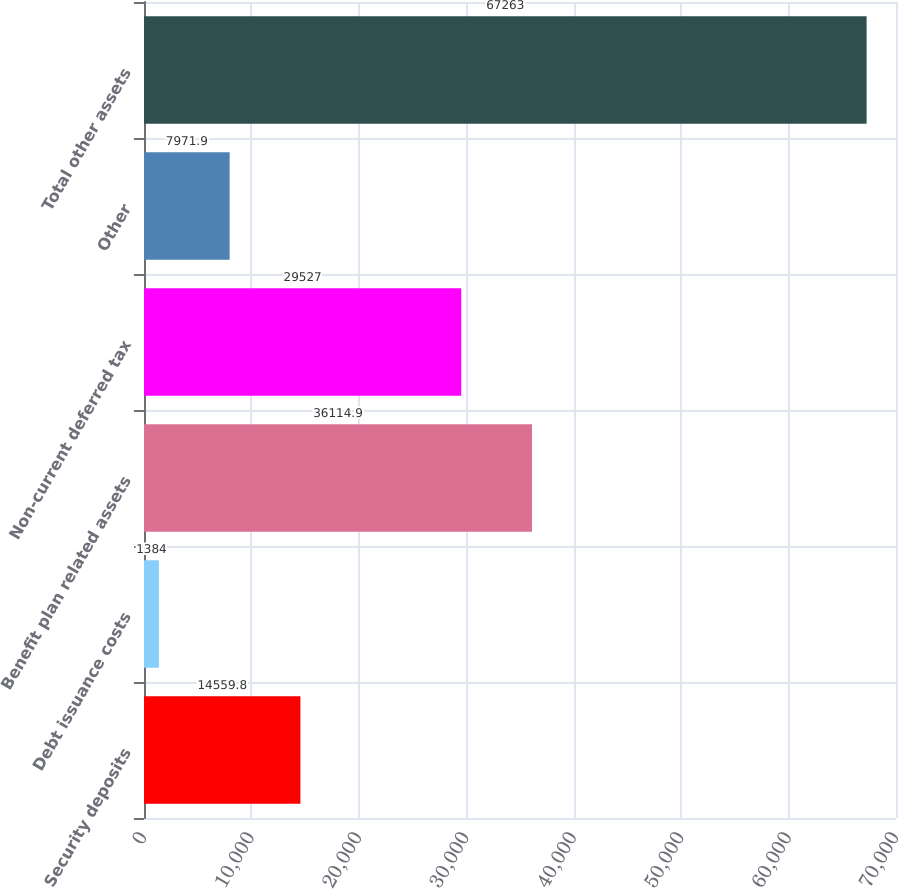Convert chart. <chart><loc_0><loc_0><loc_500><loc_500><bar_chart><fcel>Security deposits<fcel>Debt issuance costs<fcel>Benefit plan related assets<fcel>Non-current deferred tax<fcel>Other<fcel>Total other assets<nl><fcel>14559.8<fcel>1384<fcel>36114.9<fcel>29527<fcel>7971.9<fcel>67263<nl></chart> 